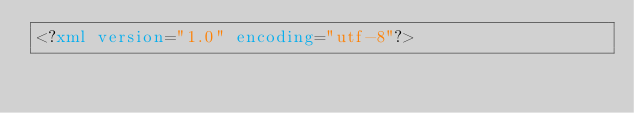<code> <loc_0><loc_0><loc_500><loc_500><_XML_><?xml version="1.0" encoding="utf-8"?></code> 